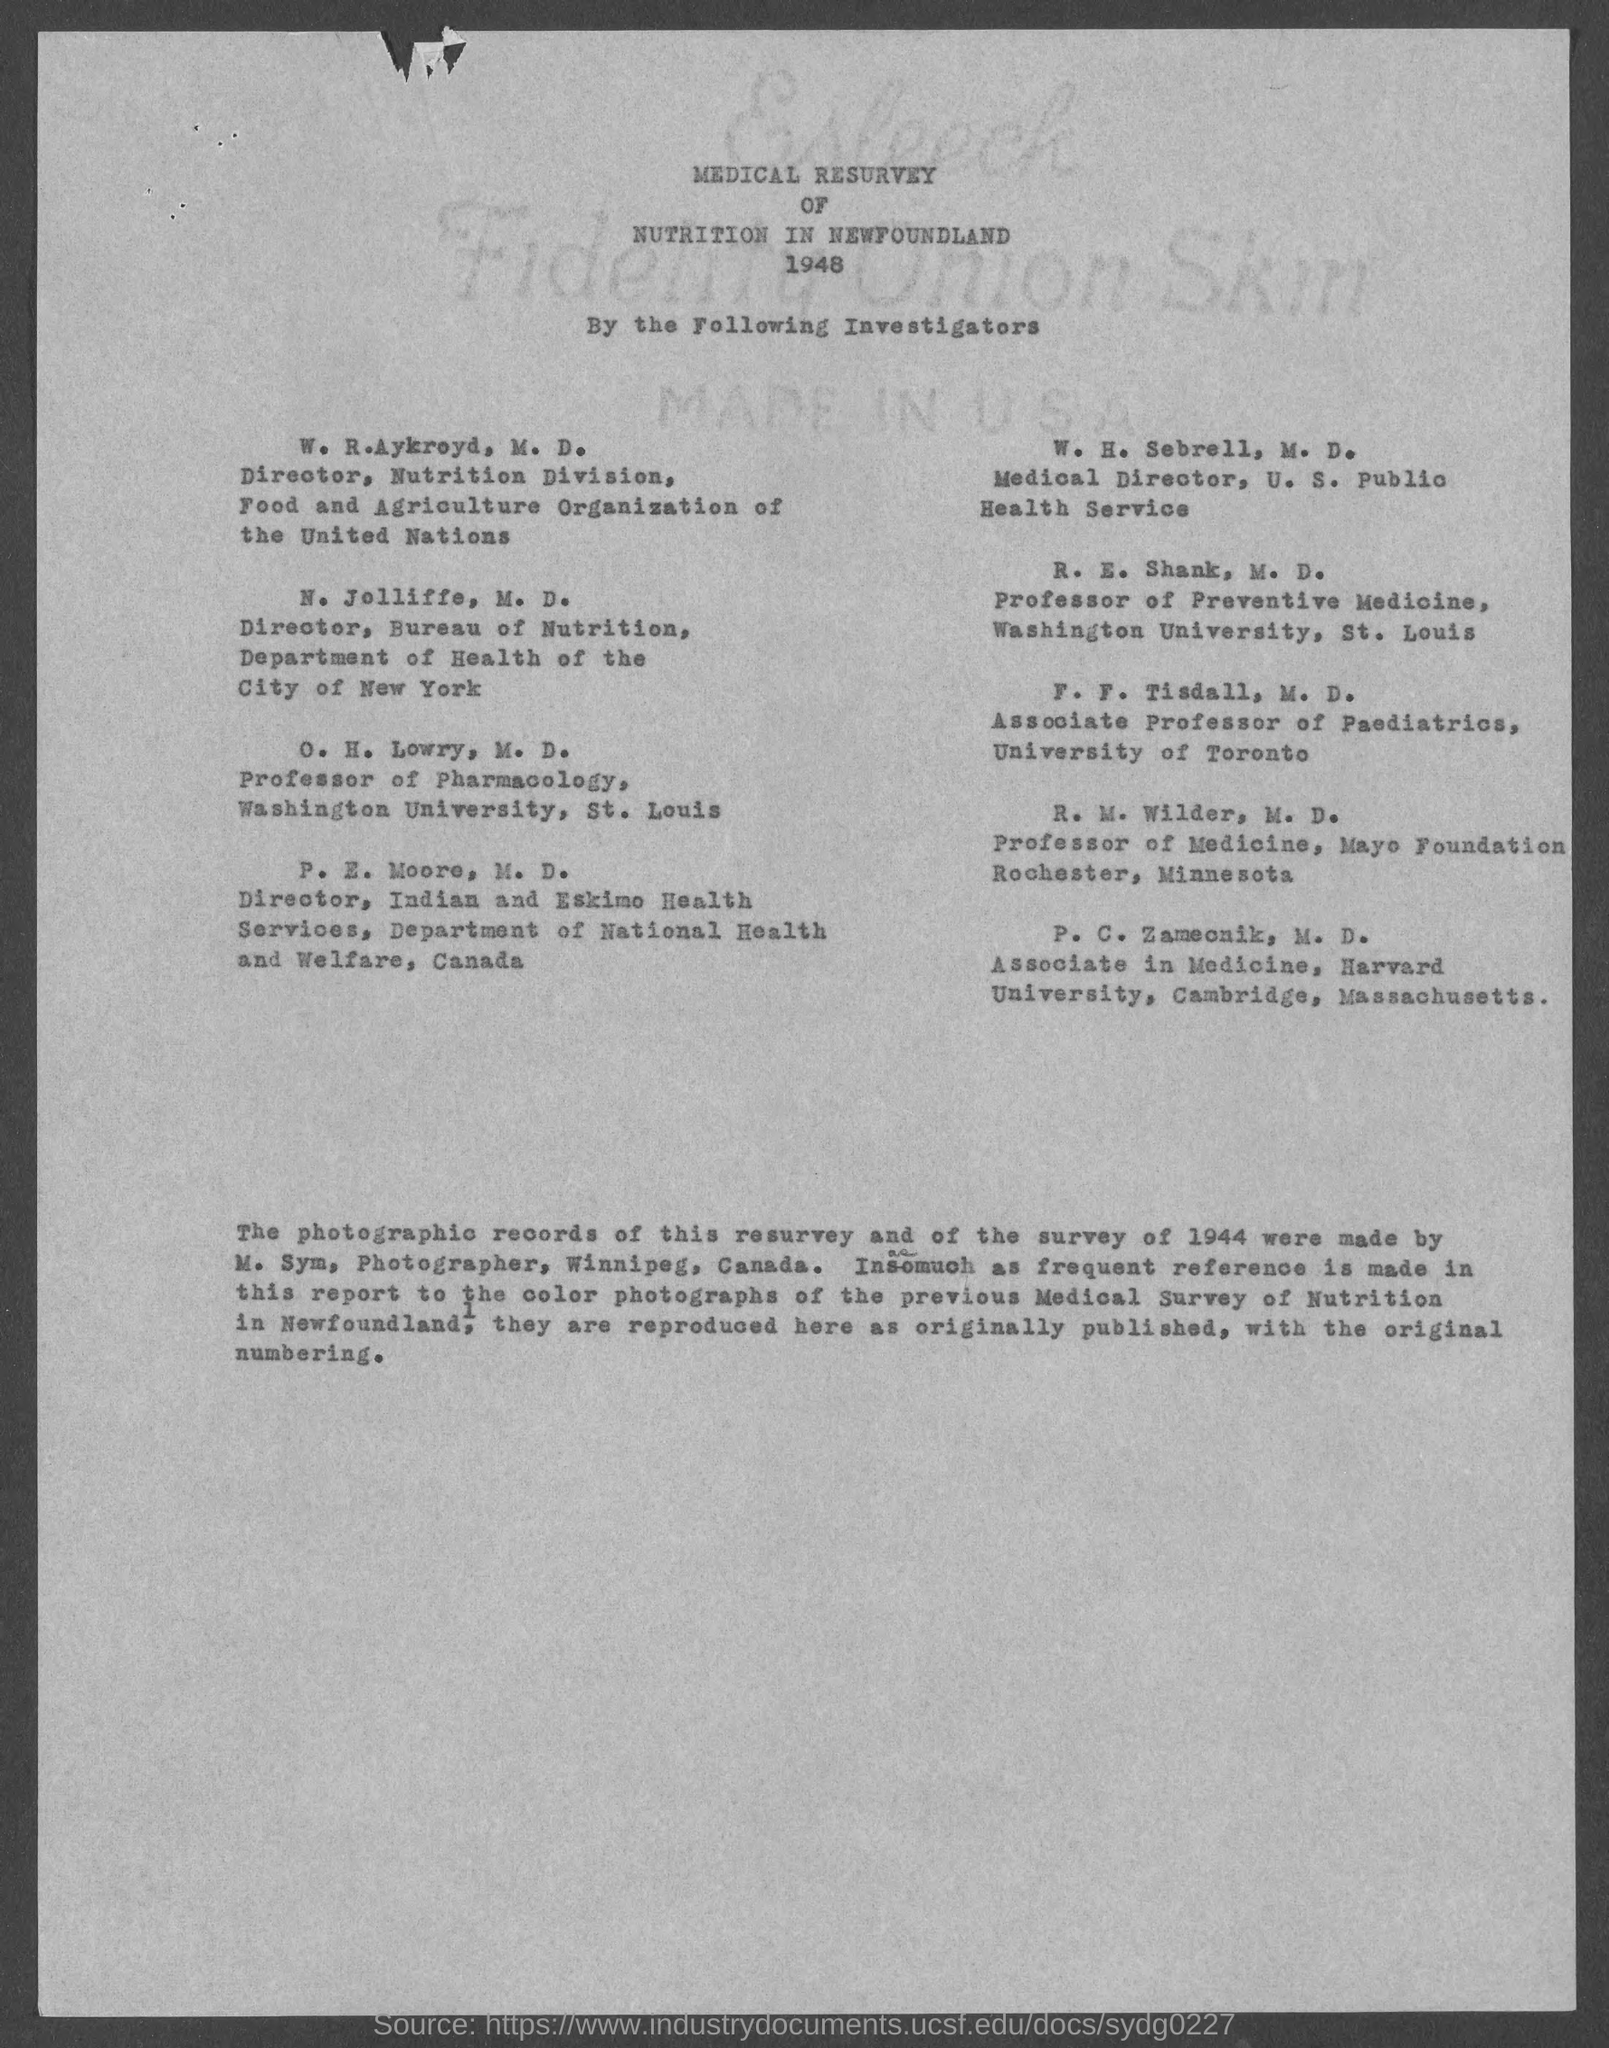What is the position of o. h. lowry, m.d.?
Provide a short and direct response. Professor of Pharmacology. What is the position of w.h. sebrell, m.d. ?
Keep it short and to the point. Medical  Director. What is the position of r.e. shank, m.d.?
Provide a short and direct response. Professor of Preventive Medicine. What is the position of f. f. tisdall, m.d. ?
Keep it short and to the point. Associate Professor of Paediatrics. What is the position of r. m. wilder, m.d.?
Your response must be concise. Professor of Medicine. What is the position of p.c. zameonik, m.d.?
Keep it short and to the point. Associate in medicine. 